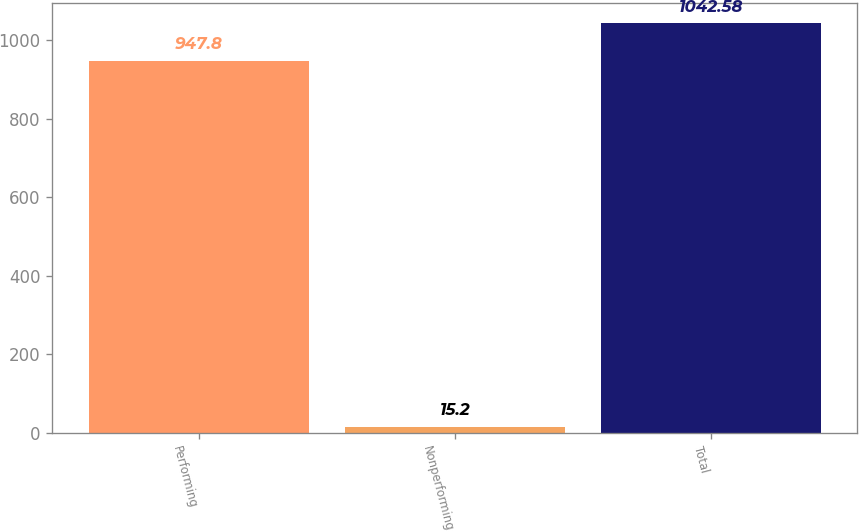Convert chart. <chart><loc_0><loc_0><loc_500><loc_500><bar_chart><fcel>Performing<fcel>Nonperforming<fcel>Total<nl><fcel>947.8<fcel>15.2<fcel>1042.58<nl></chart> 